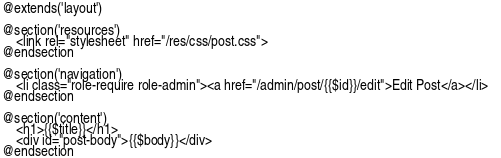Convert code to text. <code><loc_0><loc_0><loc_500><loc_500><_PHP_>@extends('layout')

@section('resources')
    <link rel="stylesheet" href="/res/css/post.css">
@endsection

@section('navigation')
    <li class="role-require role-admin"><a href="/admin/post/{{$id}}/edit">Edit Post</a></li>   
@endsection

@section('content')
    <h1>{{$title}}</h1>
    <div id="post-body">{{$body}}</div>
@endsection</code> 